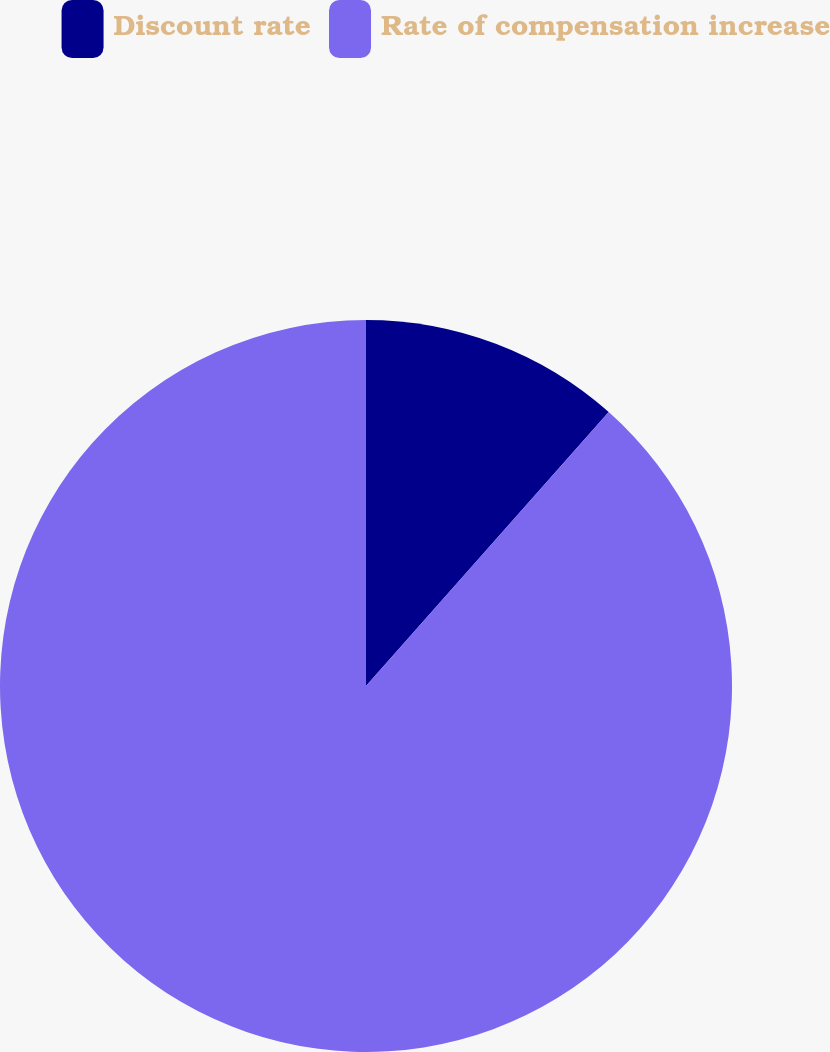Convert chart. <chart><loc_0><loc_0><loc_500><loc_500><pie_chart><fcel>Discount rate<fcel>Rate of compensation increase<nl><fcel>11.54%<fcel>88.46%<nl></chart> 